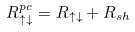Convert formula to latex. <formula><loc_0><loc_0><loc_500><loc_500>R _ { \uparrow \downarrow } ^ { p c } = R _ { \uparrow \downarrow } + R _ { s h }</formula> 